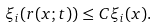Convert formula to latex. <formula><loc_0><loc_0><loc_500><loc_500>\xi _ { i } ( r ( x ; t ) ) \leq C \xi _ { i } ( x ) .</formula> 